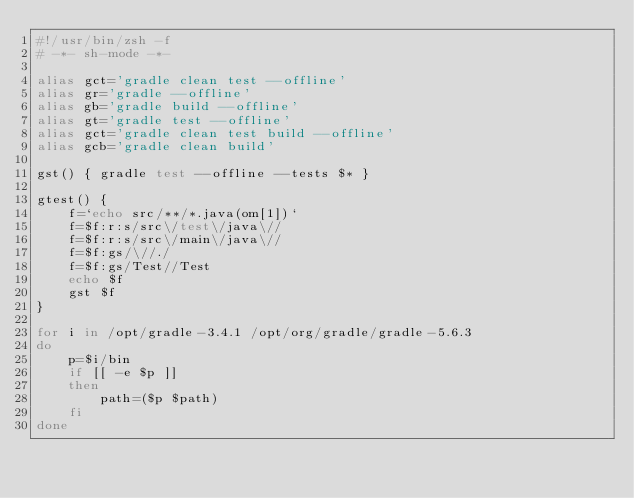<code> <loc_0><loc_0><loc_500><loc_500><_Bash_>#!/usr/bin/zsh -f
# -*- sh-mode -*-

alias gct='gradle clean test --offline'
alias gr='gradle --offline'
alias gb='gradle build --offline'
alias gt='gradle test --offline'
alias gct='gradle clean test build --offline'
alias gcb='gradle clean build'

gst() { gradle test --offline --tests $* }

gtest() {
    f=`echo src/**/*.java(om[1])`
    f=$f:r:s/src\/test\/java\//
    f=$f:r:s/src\/main\/java\//
    f=$f:gs/\//./
    f=$f:gs/Test//Test
    echo $f
    gst $f
}

for i in /opt/gradle-3.4.1 /opt/org/gradle/gradle-5.6.3
do
    p=$i/bin
    if [[ -e $p ]]
    then
        path=($p $path)
    fi
done
</code> 